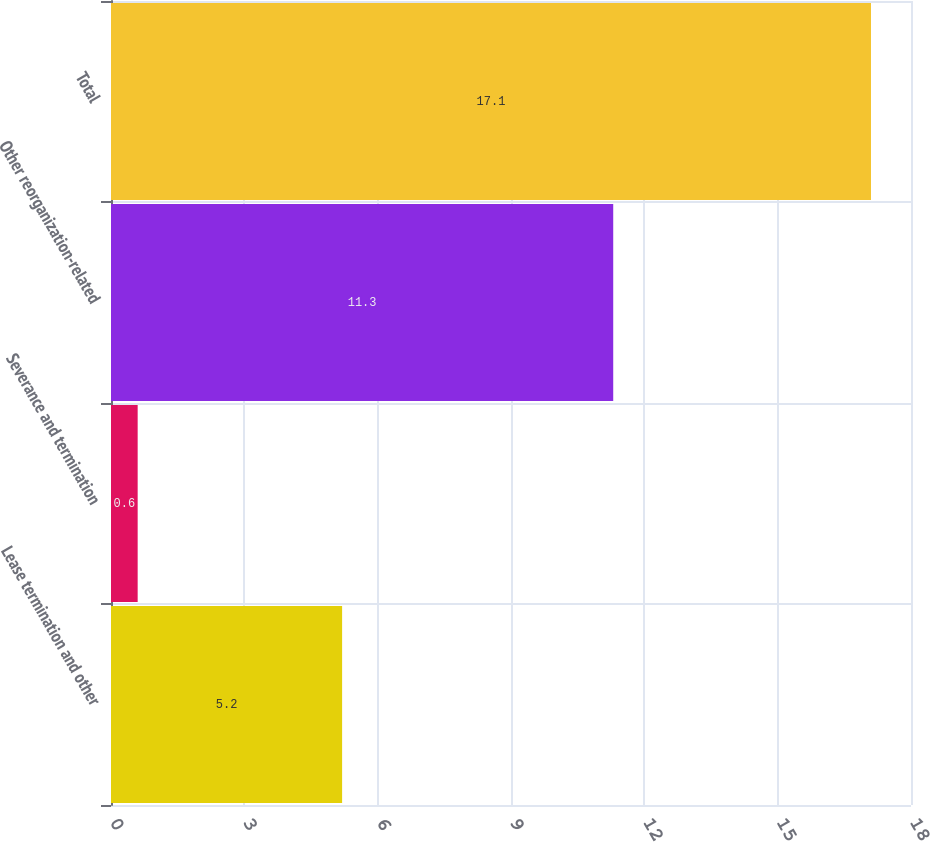Convert chart to OTSL. <chart><loc_0><loc_0><loc_500><loc_500><bar_chart><fcel>Lease termination and other<fcel>Severance and termination<fcel>Other reorganization-related<fcel>Total<nl><fcel>5.2<fcel>0.6<fcel>11.3<fcel>17.1<nl></chart> 